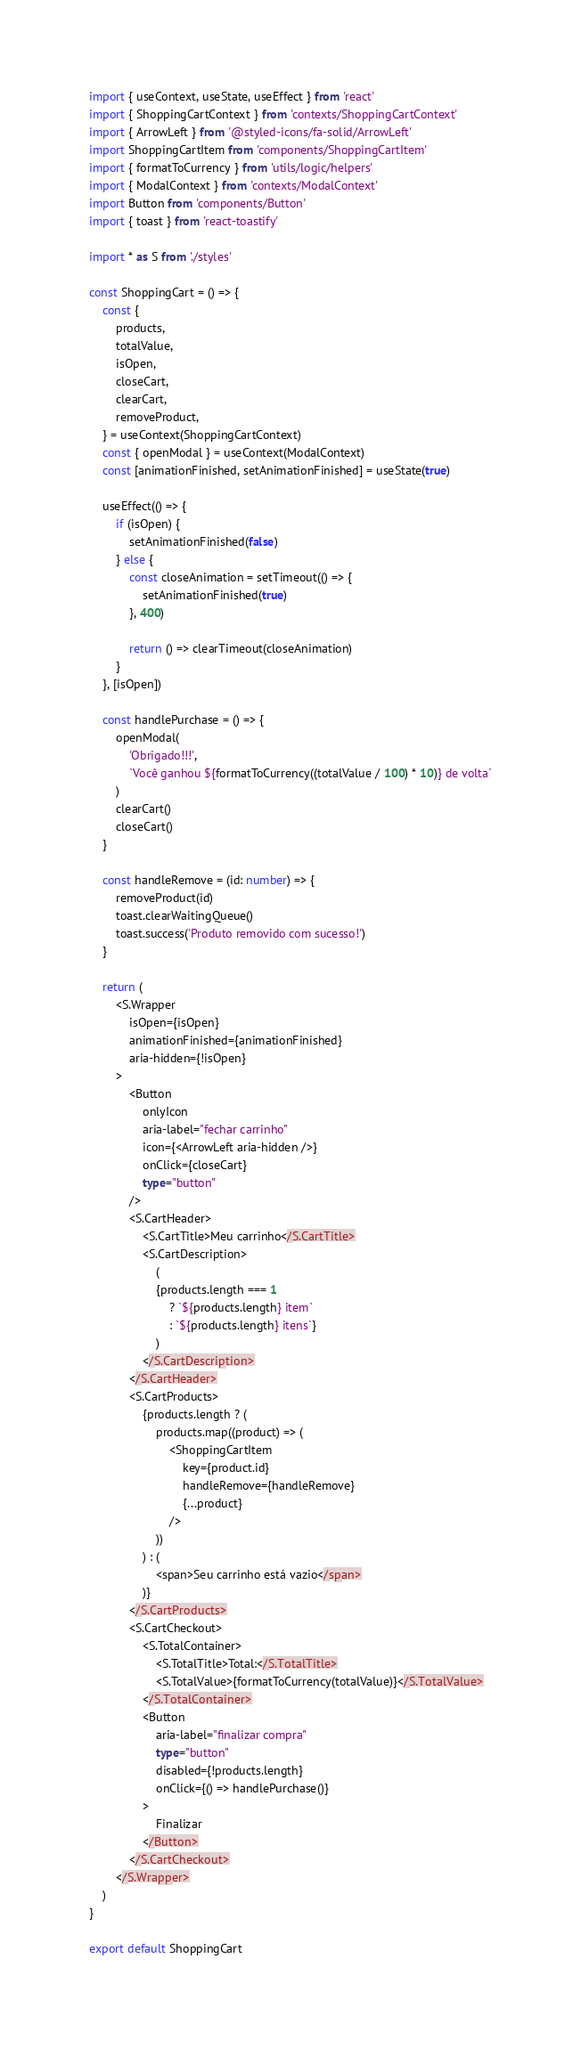<code> <loc_0><loc_0><loc_500><loc_500><_TypeScript_>import { useContext, useState, useEffect } from 'react'
import { ShoppingCartContext } from 'contexts/ShoppingCartContext'
import { ArrowLeft } from '@styled-icons/fa-solid/ArrowLeft'
import ShoppingCartItem from 'components/ShoppingCartItem'
import { formatToCurrency } from 'utils/logic/helpers'
import { ModalContext } from 'contexts/ModalContext'
import Button from 'components/Button'
import { toast } from 'react-toastify'

import * as S from './styles'

const ShoppingCart = () => {
    const {
        products,
        totalValue,
        isOpen,
        closeCart,
        clearCart,
        removeProduct,
    } = useContext(ShoppingCartContext)
    const { openModal } = useContext(ModalContext)
    const [animationFinished, setAnimationFinished] = useState(true)

    useEffect(() => {
        if (isOpen) {
            setAnimationFinished(false)
        } else {
            const closeAnimation = setTimeout(() => {
                setAnimationFinished(true)
            }, 400)

            return () => clearTimeout(closeAnimation)
        }
    }, [isOpen])

    const handlePurchase = () => {
        openModal(
            'Obrigado!!!',
            `Você ganhou ${formatToCurrency((totalValue / 100) * 10)} de volta`
        )
        clearCart()
        closeCart()
    }

    const handleRemove = (id: number) => {
        removeProduct(id)
        toast.clearWaitingQueue()
        toast.success('Produto removido com sucesso!')
    }

    return (
        <S.Wrapper
            isOpen={isOpen}
            animationFinished={animationFinished}
            aria-hidden={!isOpen}
        >
            <Button
                onlyIcon
                aria-label="fechar carrinho"
                icon={<ArrowLeft aria-hidden />}
                onClick={closeCart}
                type="button"
            />
            <S.CartHeader>
                <S.CartTitle>Meu carrinho</S.CartTitle>
                <S.CartDescription>
                    (
                    {products.length === 1
                        ? `${products.length} item`
                        : `${products.length} itens`}
                    )
                </S.CartDescription>
            </S.CartHeader>
            <S.CartProducts>
                {products.length ? (
                    products.map((product) => (
                        <ShoppingCartItem
                            key={product.id}
                            handleRemove={handleRemove}
                            {...product}
                        />
                    ))
                ) : (
                    <span>Seu carrinho está vazio</span>
                )}
            </S.CartProducts>
            <S.CartCheckout>
                <S.TotalContainer>
                    <S.TotalTitle>Total:</S.TotalTitle>
                    <S.TotalValue>{formatToCurrency(totalValue)}</S.TotalValue>
                </S.TotalContainer>
                <Button
                    aria-label="finalizar compra"
                    type="button"
                    disabled={!products.length}
                    onClick={() => handlePurchase()}
                >
                    Finalizar
                </Button>
            </S.CartCheckout>
        </S.Wrapper>
    )
}

export default ShoppingCart
</code> 